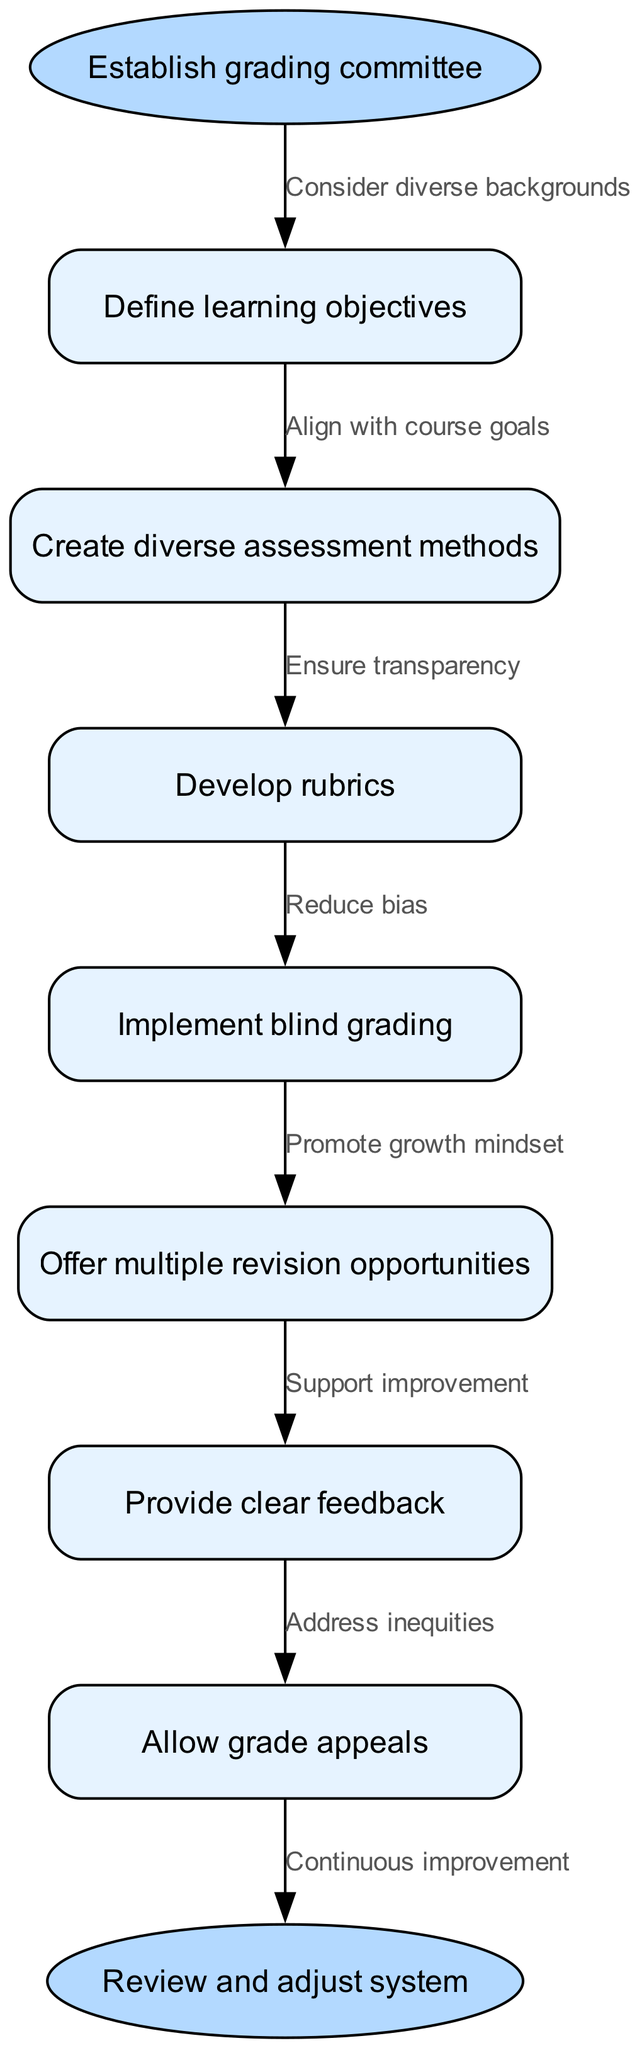What is the starting point of the flow chart? The flow chart begins with the instruction "Establish grading committee" as the first node. This is identified as the starting node in the provided data.
Answer: Establish grading committee What is the final step in the grading system? The last node in the flow chart indicates the final step is "Review and adjust system." This is designated as the end node in the data.
Answer: Review and adjust system How many nodes are there in total? The diagram contains 8 nodes: 1 start node, 6 intermediate nodes, and 1 end node. Summing these gives a total of 8 nodes.
Answer: 8 What method is suggested to reduce bias in grading? The flow chart includes "Implement blind grading" as a method specifically indicated to help reduce bias in the grading system.
Answer: Implement blind grading Which step follows the "Define learning objectives"? The next step following "Define learning objectives" is "Create diverse assessment methods." This can be deduced from the sequence of nodes in the diagram.
Answer: Create diverse assessment methods What is the label for the edge connecting "Develop rubrics" to the next node? The edge connecting "Develop rubrics" to "Implement blind grading" is labeled "Ensure transparency," indicating the rationale for this step.
Answer: Ensure transparency How many edges are used in the diagram? The flow chart utilizes 7 edges, representing connections between the 7 steps in the grading process. This is calculated as there are 7 transitional connections between the nodes.
Answer: 7 What is the purpose of offering multiple revision opportunities? "Offer multiple revision opportunities" is aimed to "Promote growth mindset," as indicated by the corresponding edge label, emphasizing the supportive role of this step in the grading system.
Answer: Promote growth mindset Which step is directly before "Provide clear feedback"? The step directly before "Provide clear feedback" is "Implement blind grading." This follows logically in the order of execution within the chart.
Answer: Implement blind grading 